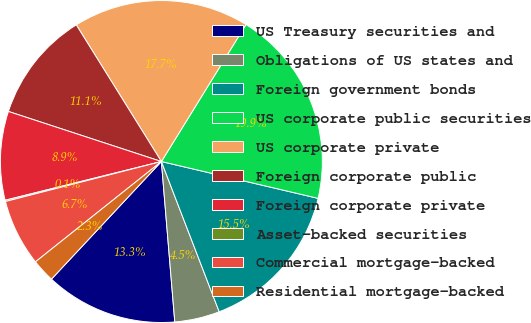Convert chart. <chart><loc_0><loc_0><loc_500><loc_500><pie_chart><fcel>US Treasury securities and<fcel>Obligations of US states and<fcel>Foreign government bonds<fcel>US corporate public securities<fcel>US corporate private<fcel>Foreign corporate public<fcel>Foreign corporate private<fcel>Asset-backed securities<fcel>Commercial mortgage-backed<fcel>Residential mortgage-backed<nl><fcel>13.29%<fcel>4.52%<fcel>15.48%<fcel>19.87%<fcel>17.67%<fcel>11.1%<fcel>8.9%<fcel>0.13%<fcel>6.71%<fcel>2.33%<nl></chart> 